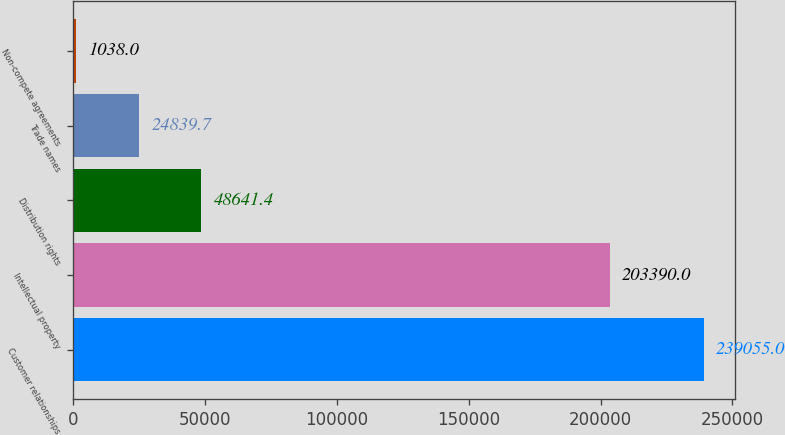<chart> <loc_0><loc_0><loc_500><loc_500><bar_chart><fcel>Customer relationships<fcel>Intellectual property<fcel>Distribution rights<fcel>Trade names<fcel>Non-compete agreements<nl><fcel>239055<fcel>203390<fcel>48641.4<fcel>24839.7<fcel>1038<nl></chart> 